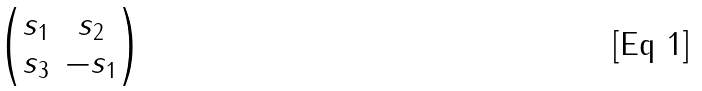<formula> <loc_0><loc_0><loc_500><loc_500>\begin{pmatrix} s _ { 1 } & s _ { 2 } \\ s _ { 3 } & - s _ { 1 } \end{pmatrix}</formula> 